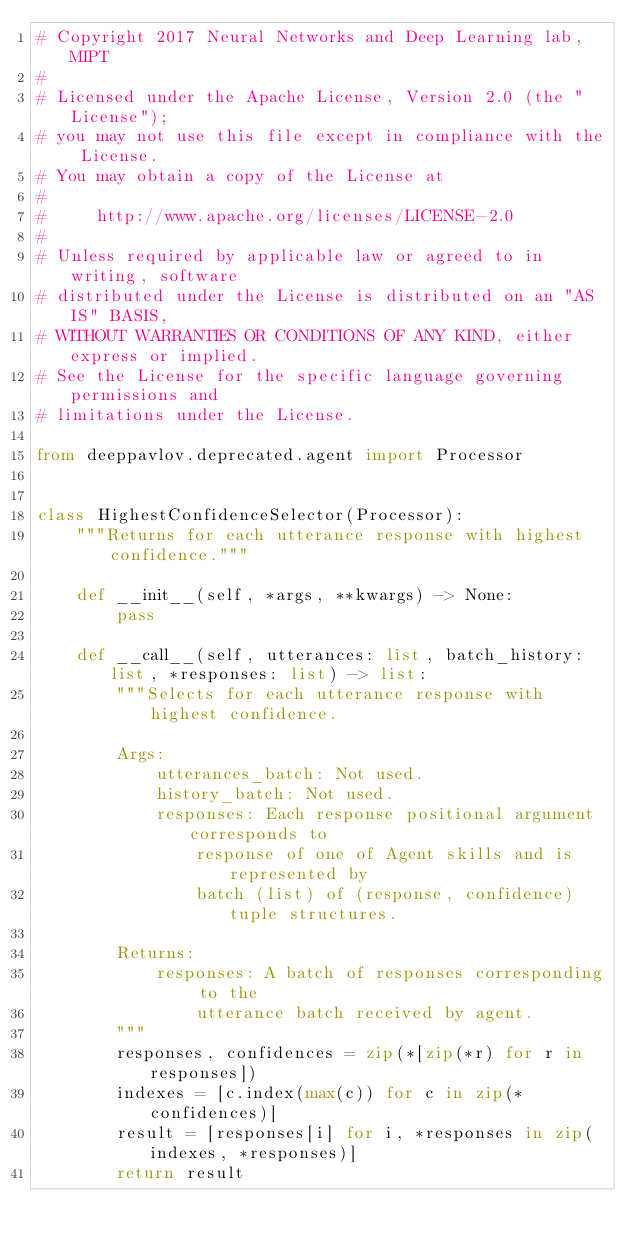Convert code to text. <code><loc_0><loc_0><loc_500><loc_500><_Python_># Copyright 2017 Neural Networks and Deep Learning lab, MIPT
#
# Licensed under the Apache License, Version 2.0 (the "License");
# you may not use this file except in compliance with the License.
# You may obtain a copy of the License at
#
#     http://www.apache.org/licenses/LICENSE-2.0
#
# Unless required by applicable law or agreed to in writing, software
# distributed under the License is distributed on an "AS IS" BASIS,
# WITHOUT WARRANTIES OR CONDITIONS OF ANY KIND, either express or implied.
# See the License for the specific language governing permissions and
# limitations under the License.

from deeppavlov.deprecated.agent import Processor


class HighestConfidenceSelector(Processor):
    """Returns for each utterance response with highest confidence."""

    def __init__(self, *args, **kwargs) -> None:
        pass

    def __call__(self, utterances: list, batch_history: list, *responses: list) -> list:
        """Selects for each utterance response with highest confidence.

        Args:
            utterances_batch: Not used.
            history_batch: Not used.
            responses: Each response positional argument corresponds to
                response of one of Agent skills and is represented by
                batch (list) of (response, confidence) tuple structures.

        Returns:
            responses: A batch of responses corresponding to the
                utterance batch received by agent.
        """
        responses, confidences = zip(*[zip(*r) for r in responses])
        indexes = [c.index(max(c)) for c in zip(*confidences)]
        result = [responses[i] for i, *responses in zip(indexes, *responses)]
        return result
</code> 